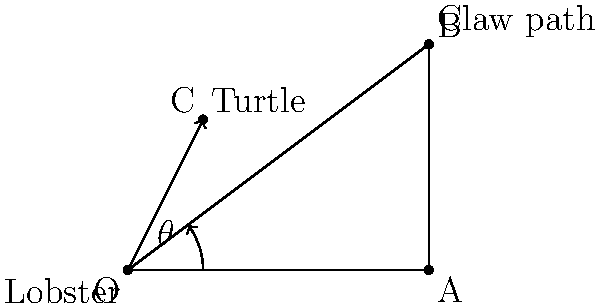A grumpy lobster at point O aims to intercept a moving sea turtle at point C with its claw. The lobster's claw follows a straight path from O to B. Given that OA = 4 units, AB = 3 units, and OC = $\sqrt{5}$ units, calculate the angle $\theta$ (in degrees) between the lobster's claw path (OB) and the direct path to the turtle (OC) for a successful interception. To solve this problem, we'll follow these steps:

1) First, let's identify the triangles in the diagram. We have two right triangles: OAB and OXC (where X is the projection of C onto OA).

2) In triangle OAB:
   $\tan \alpha = \frac{AB}{OA} = \frac{3}{4}$
   $\alpha = \arctan(\frac{3}{4})$

3) In triangle OXC:
   $OC = \sqrt{5}$
   $OX = 1$ (given)
   $XC = 2$ (given)
   $\tan \beta = \frac{XC}{OX} = \frac{2}{1} = 2$
   $\beta = \arctan(2)$

4) The angle $\theta$ we're looking for is the difference between these two angles:
   $\theta = \alpha - \beta$

5) Calculate:
   $\alpha = \arctan(\frac{3}{4}) \approx 36.87°$
   $\beta = \arctan(2) \approx 63.43°$

6) Therefore:
   $\theta = 36.87° - 63.43° \approx -26.56°$

7) The negative angle indicates that the lobster's claw path is actually clockwise from the direct path to the turtle.

8) Taking the absolute value for the final answer:
   $|\theta| \approx 26.56°$
Answer: $26.56°$ 